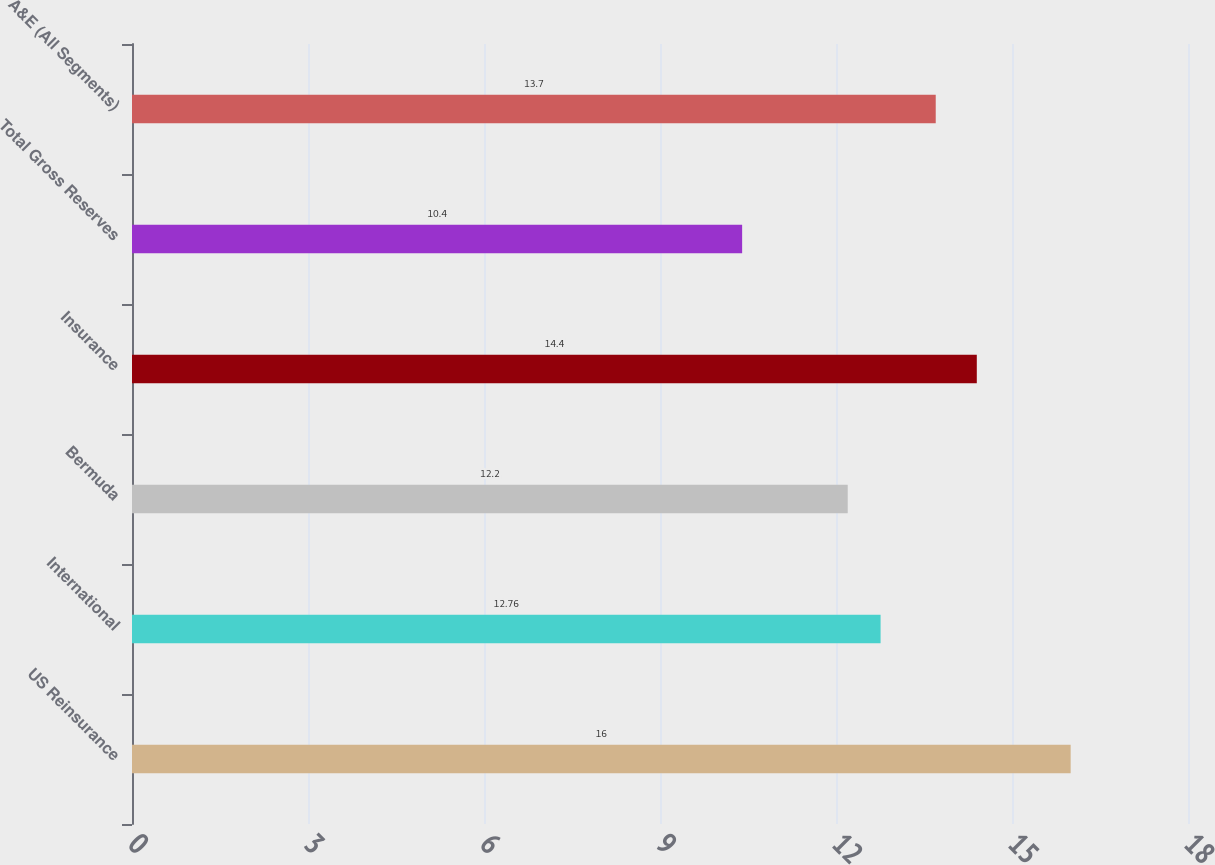Convert chart. <chart><loc_0><loc_0><loc_500><loc_500><bar_chart><fcel>US Reinsurance<fcel>International<fcel>Bermuda<fcel>Insurance<fcel>Total Gross Reserves<fcel>A&E (All Segments)<nl><fcel>16<fcel>12.76<fcel>12.2<fcel>14.4<fcel>10.4<fcel>13.7<nl></chart> 